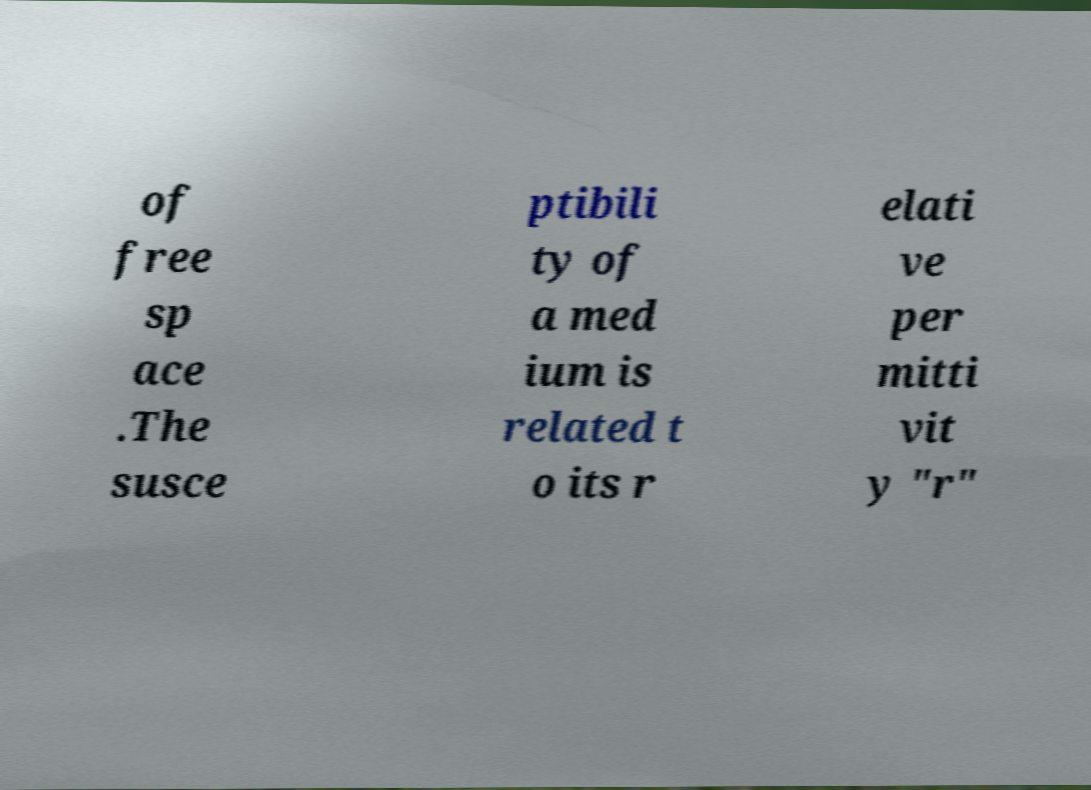Could you extract and type out the text from this image? of free sp ace .The susce ptibili ty of a med ium is related t o its r elati ve per mitti vit y "r" 